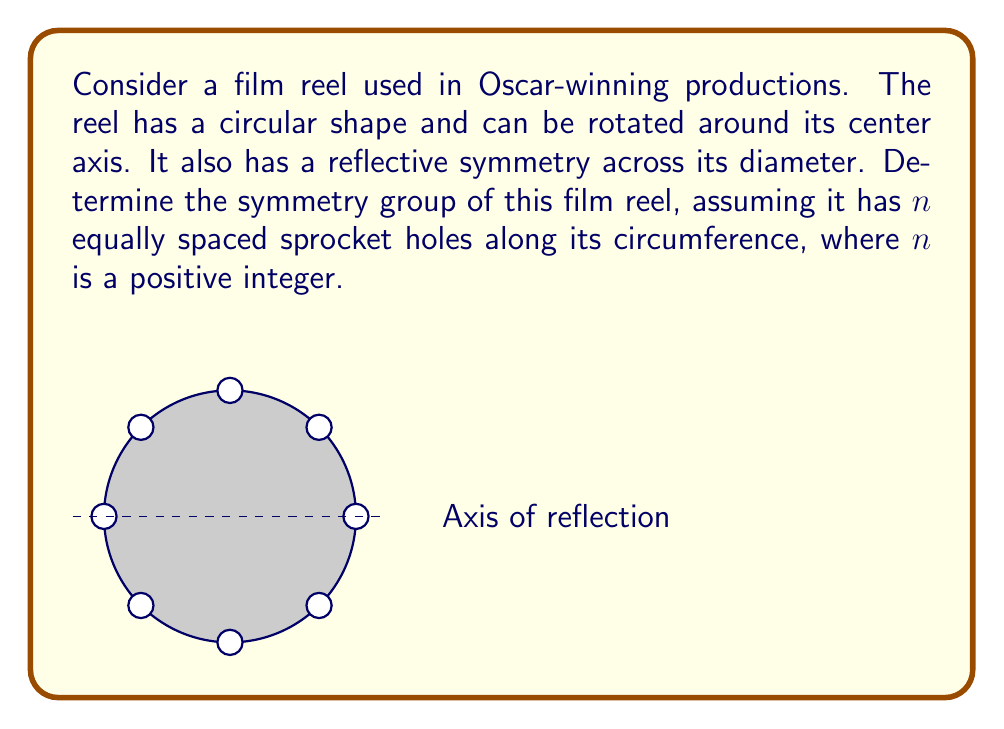Provide a solution to this math problem. To determine the symmetry group of the film reel, we need to consider both rotational and reflective symmetries:

1. Rotational symmetry:
   - The reel can be rotated by $\frac{360°}{n}$ and maintain its appearance.
   - This gives us $n$ rotational symmetries, including the identity rotation.

2. Reflective symmetry:
   - The reel has reflective symmetry across any diameter.
   - There are $n$ axes of reflection (one through each sprocket hole and one between each pair).

3. Group structure:
   - The rotations form a cyclic subgroup $C_n$ of order $n$.
   - Each reflection, when composed with the rotations, generates $n$ more symmetries.
   - The total number of symmetries is $2n$.

4. Identifying the group:
   - This group with $n$ rotations and $n$ reflections is isomorphic to the dihedral group $D_n$.
   - $D_n$ is the symmetry group of a regular $n$-gon.

5. Group properties:
   - $|D_n| = 2n$
   - $D_n$ is non-abelian for $n \geq 3$
   - It has the presentation: $D_n = \langle r, s | r^n = s^2 = 1, srs = r^{-1} \rangle$
     where $r$ represents rotation and $s$ represents reflection.

Therefore, the symmetry group of the film reel with $n$ equally spaced sprocket holes is isomorphic to the dihedral group $D_n$.
Answer: $D_n$ 